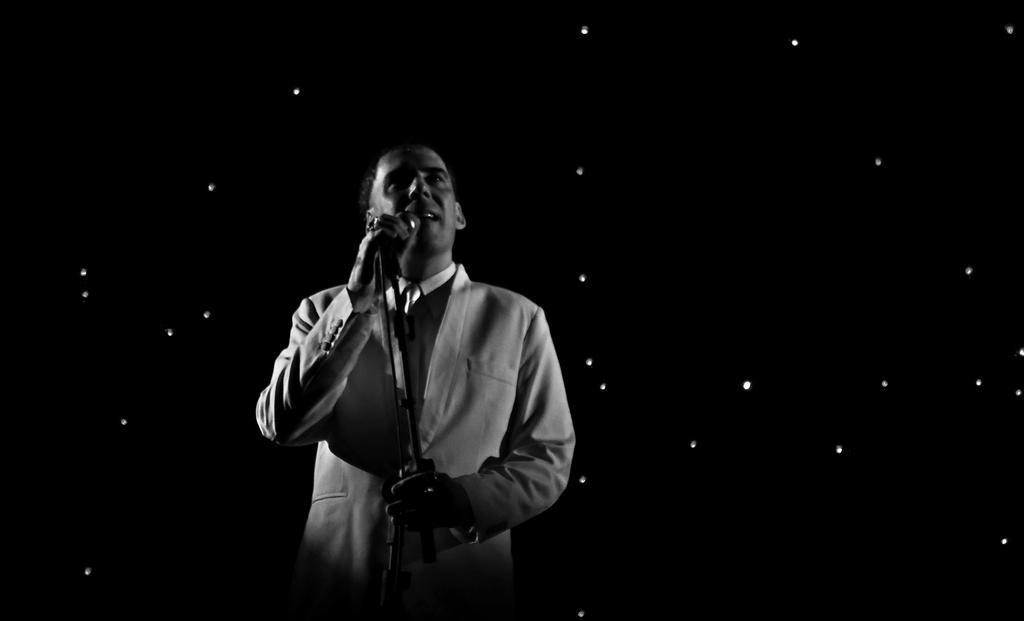Describe this image in one or two sentences. In this image there is a person standing and holding a mic in his hand. 